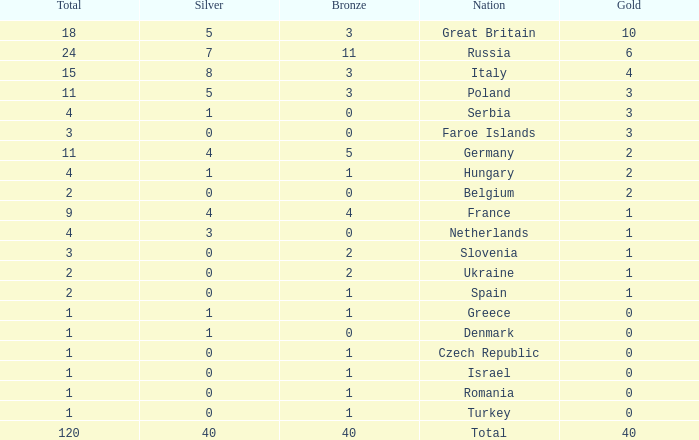What Nation has a Gold entry that is greater than 0, a Total that is greater than 2, a Silver entry that is larger than 1, and 0 Bronze? Netherlands. 